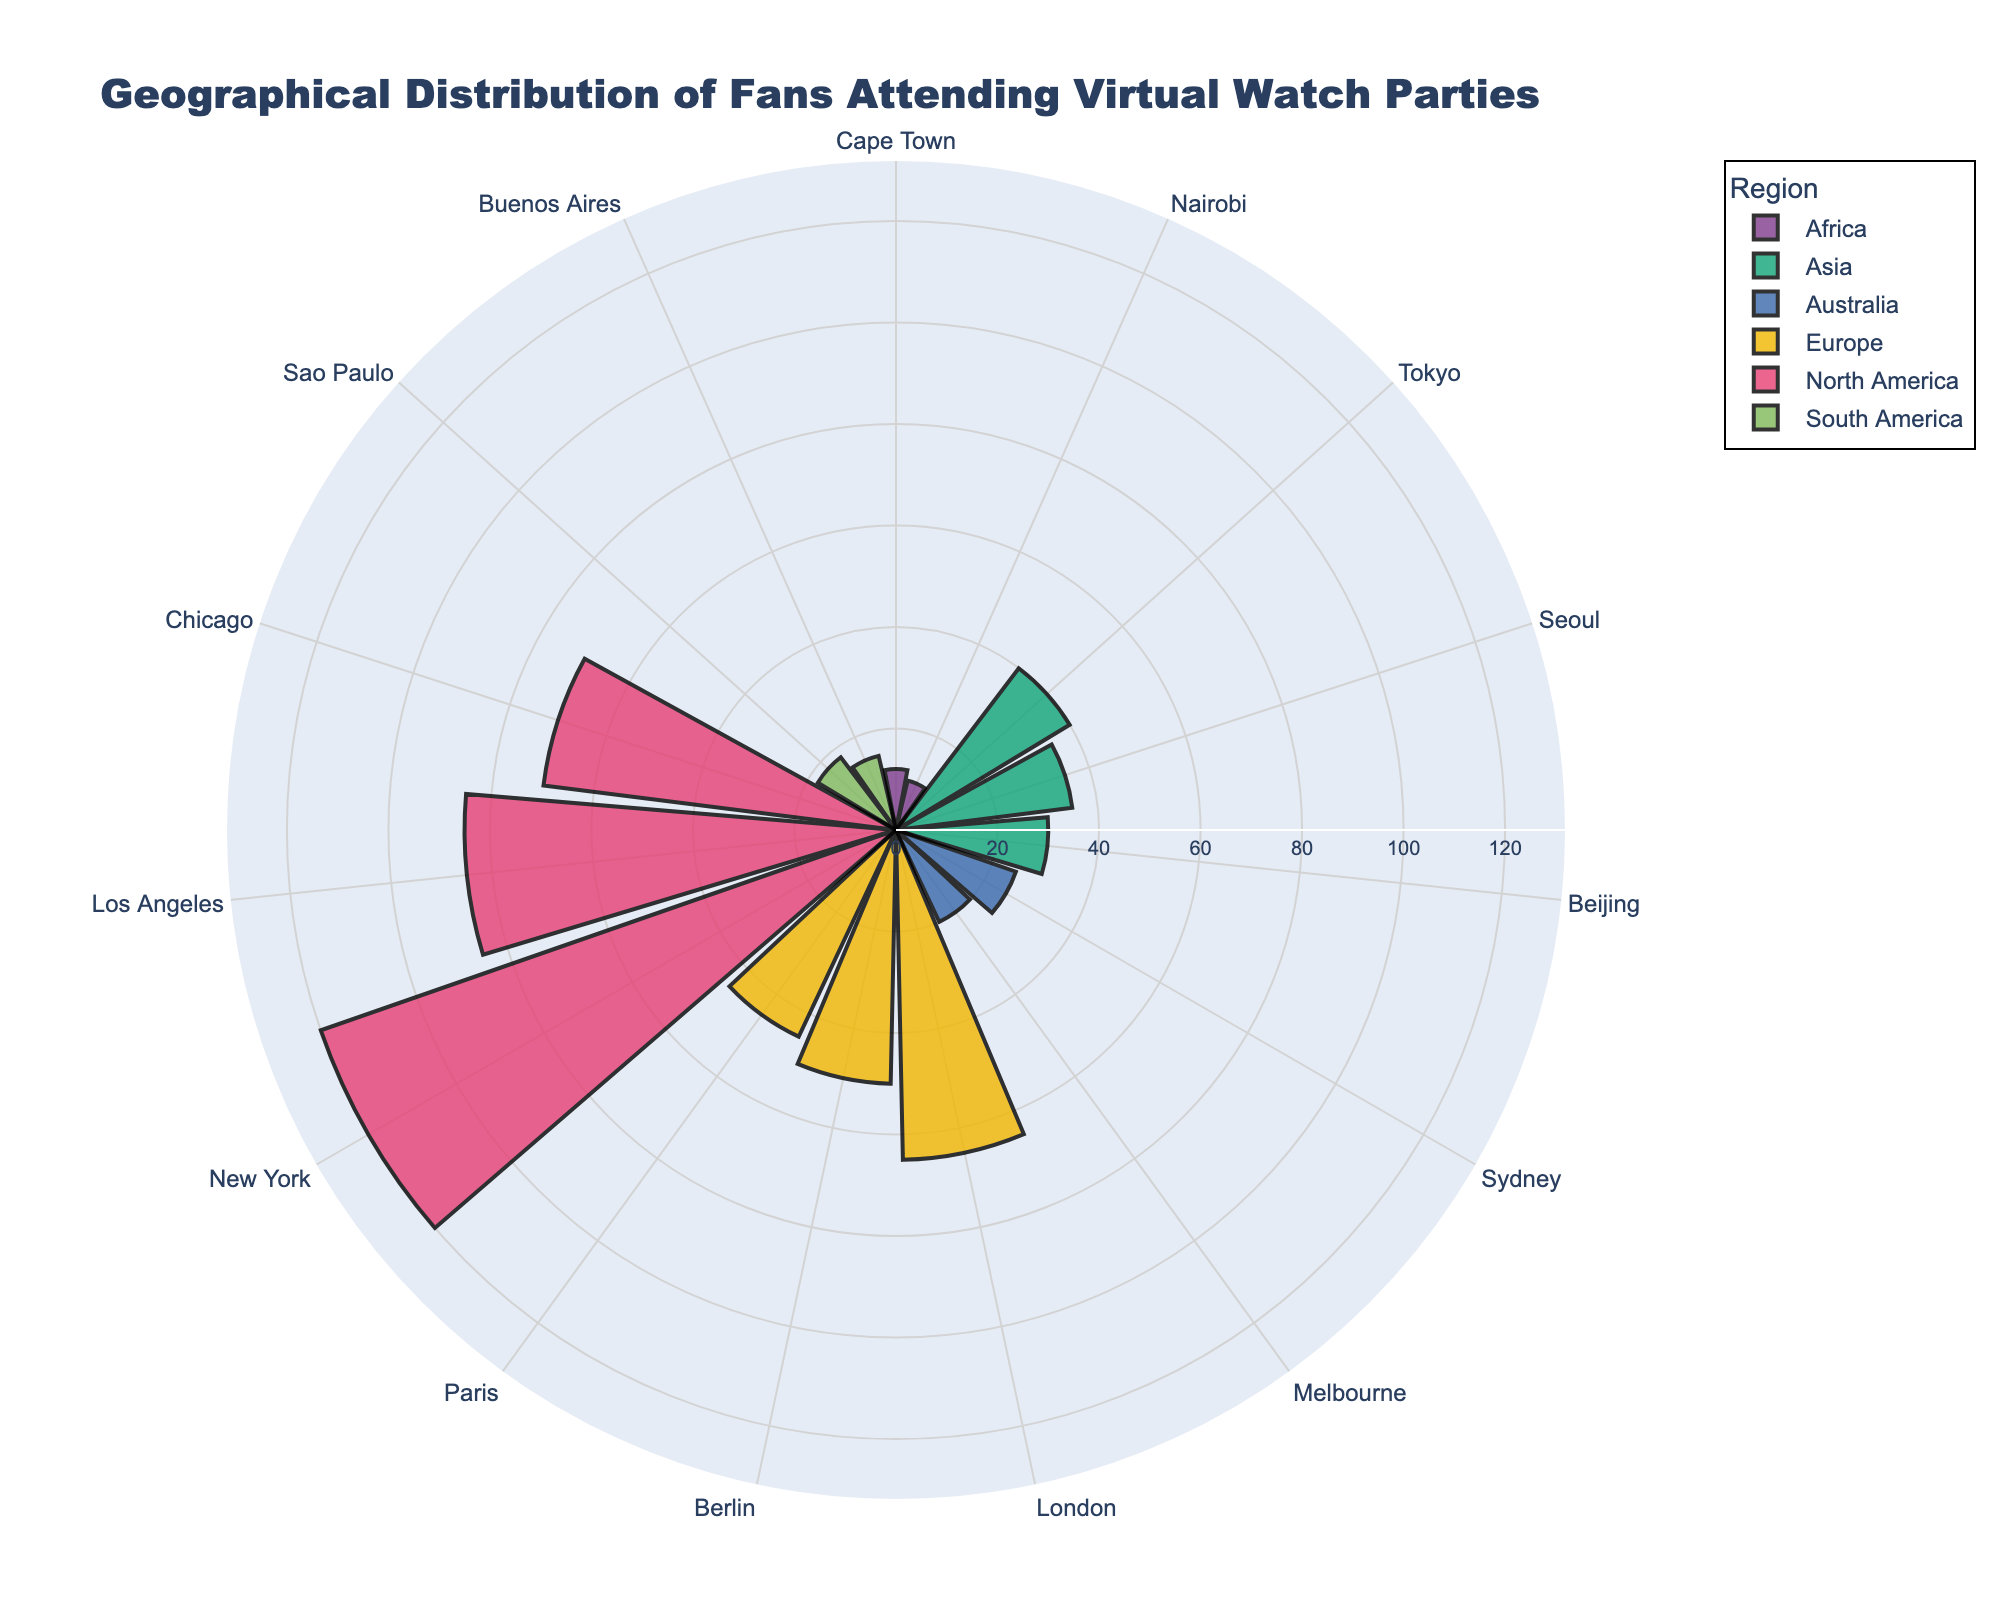What's the title of the figure? The title is typically displayed at the top of the chart. In this case, it reads: "Geographical Distribution of Fans Attending Virtual Watch Parties."
Answer: Geographical Distribution of Fans Attending Virtual Watch Parties How many regions are represented in this figure? By examining the legend or the different colors used, we can see that there are six distinct regions represented in unique colors: North America, Europe, Asia, Australia, South America, and Africa.
Answer: Six Which city has the highest number of attendees? By looking at the length of the bars in the polar chart, New York has the longest bar indicating the highest number of attendees.
Answer: New York What's the total number of attendees from Europe? Summing up the attendees from London (65), Berlin (50), and Paris (45) gives us 65 + 50 + 45 = 160.
Answer: 160 Which region has fewer attendees, Australia or South America? By comparing the total number of attendees for each region: Australia (Sydney: 25, Melbourne: 20) = 45, and South America (Sao Paulo: 18, Buenos Aires: 15) = 33. Therefore, South America has fewer attendees.
Answer: South America How many cities have more than 50 attendees? By examining each city's bar in the polar chart and counting those with a length representing more than 50 attendees, we find that New York, Los Angeles, and London have more than 50 attendees.
Answer: Three Which Asian city has the least number of attendees? By comparing the lengths of the bars for the Asian cities, Beijing has the shortest bar indicating the least number of attendees among Tokyo, Seoul, and Beijing.
Answer: Beijing What's the average number of attendees for North America? The cities in North America are New York (120), Los Angeles (85), and Chicago (70). Average = (120 + 85 + 70) / 3 = 91.67 (rounded to two decimal places).
Answer: 91.67 Which city in Africa has more attendees, Cape Town or Nairobi? By comparing the lengths of the bars for Cape Town (12) and Nairobi (10), Cape Town has more attendees.
Answer: Cape Town In the figure, which city has exactly 10 attendees? By looking at the lengths of the bars and corresponding labels, Nairobi is the city that has exactly 10 attendees.
Answer: Nairobi 